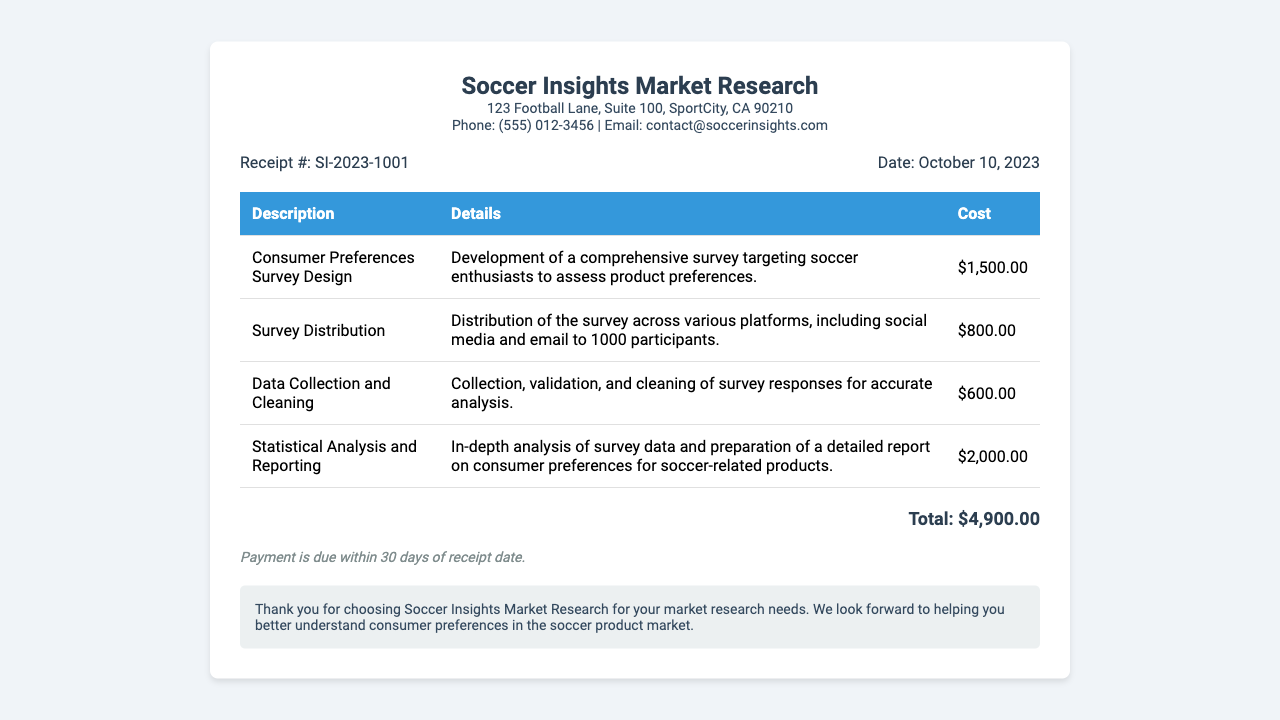What is the total cost for the services? The total cost is listed at the bottom of the receipt, summarizing all individual service costs.
Answer: $4,900.00 What is the receipt number? The receipt number is found in the receipt details section to uniquely identify this transaction.
Answer: SI-2023-1001 When was the receipt issued? The date of issuance is provided in the receipt details section, indicating when the services were billed.
Answer: October 10, 2023 How much was spent on survey distribution? The cost breakdown includes the specific amount allocated for survey distribution in the itemized list.
Answer: $800.00 How many participants were targeted for the survey? The document specifies the number of participants included in the survey distribution description.
Answer: 1000 participants What is included in the statistical analysis? The description of the statistical analysis provides insights into the extent and purpose of the analysis performed.
Answer: In-depth analysis of survey data What is the payment term? The payment terms are mentioned at the bottom of the receipt, indicating when payment is expected.
Answer: Payment is due within 30 days What topic does the consumer preferences survey address? The purpose of the survey is mentioned in the description of the survey design section.
Answer: Soccer-related products What company issued this receipt? The header of the receipt includes the name of the company providing the market research services.
Answer: Soccer Insights Market Research 